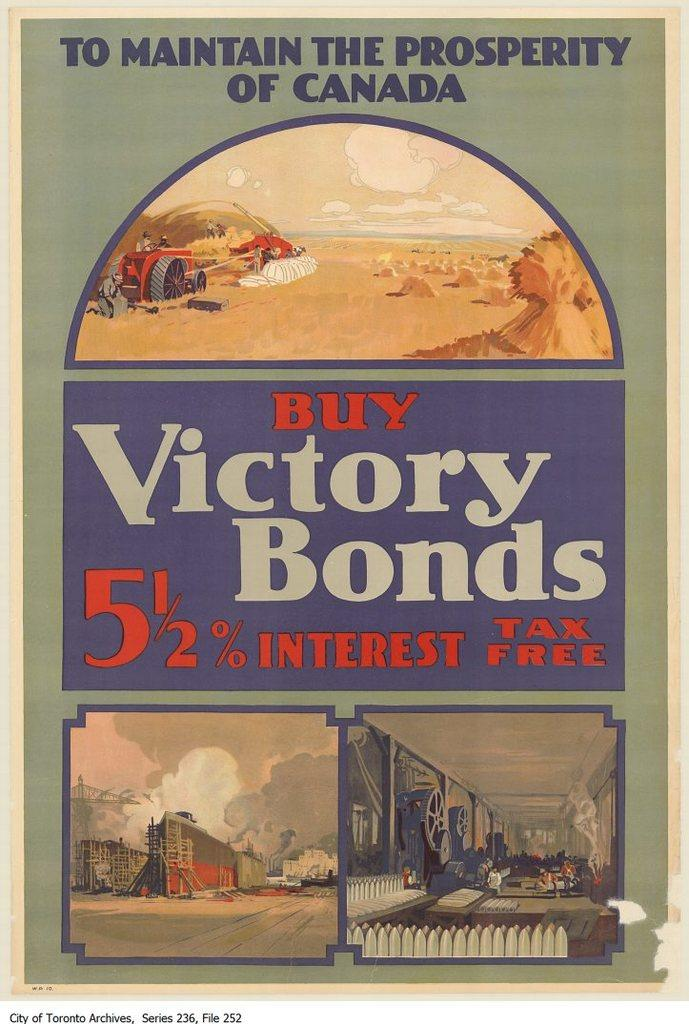<image>
Write a terse but informative summary of the picture. A poster for Canadian victory bonds has drawings of a farmer, a building, and a factory on it. 